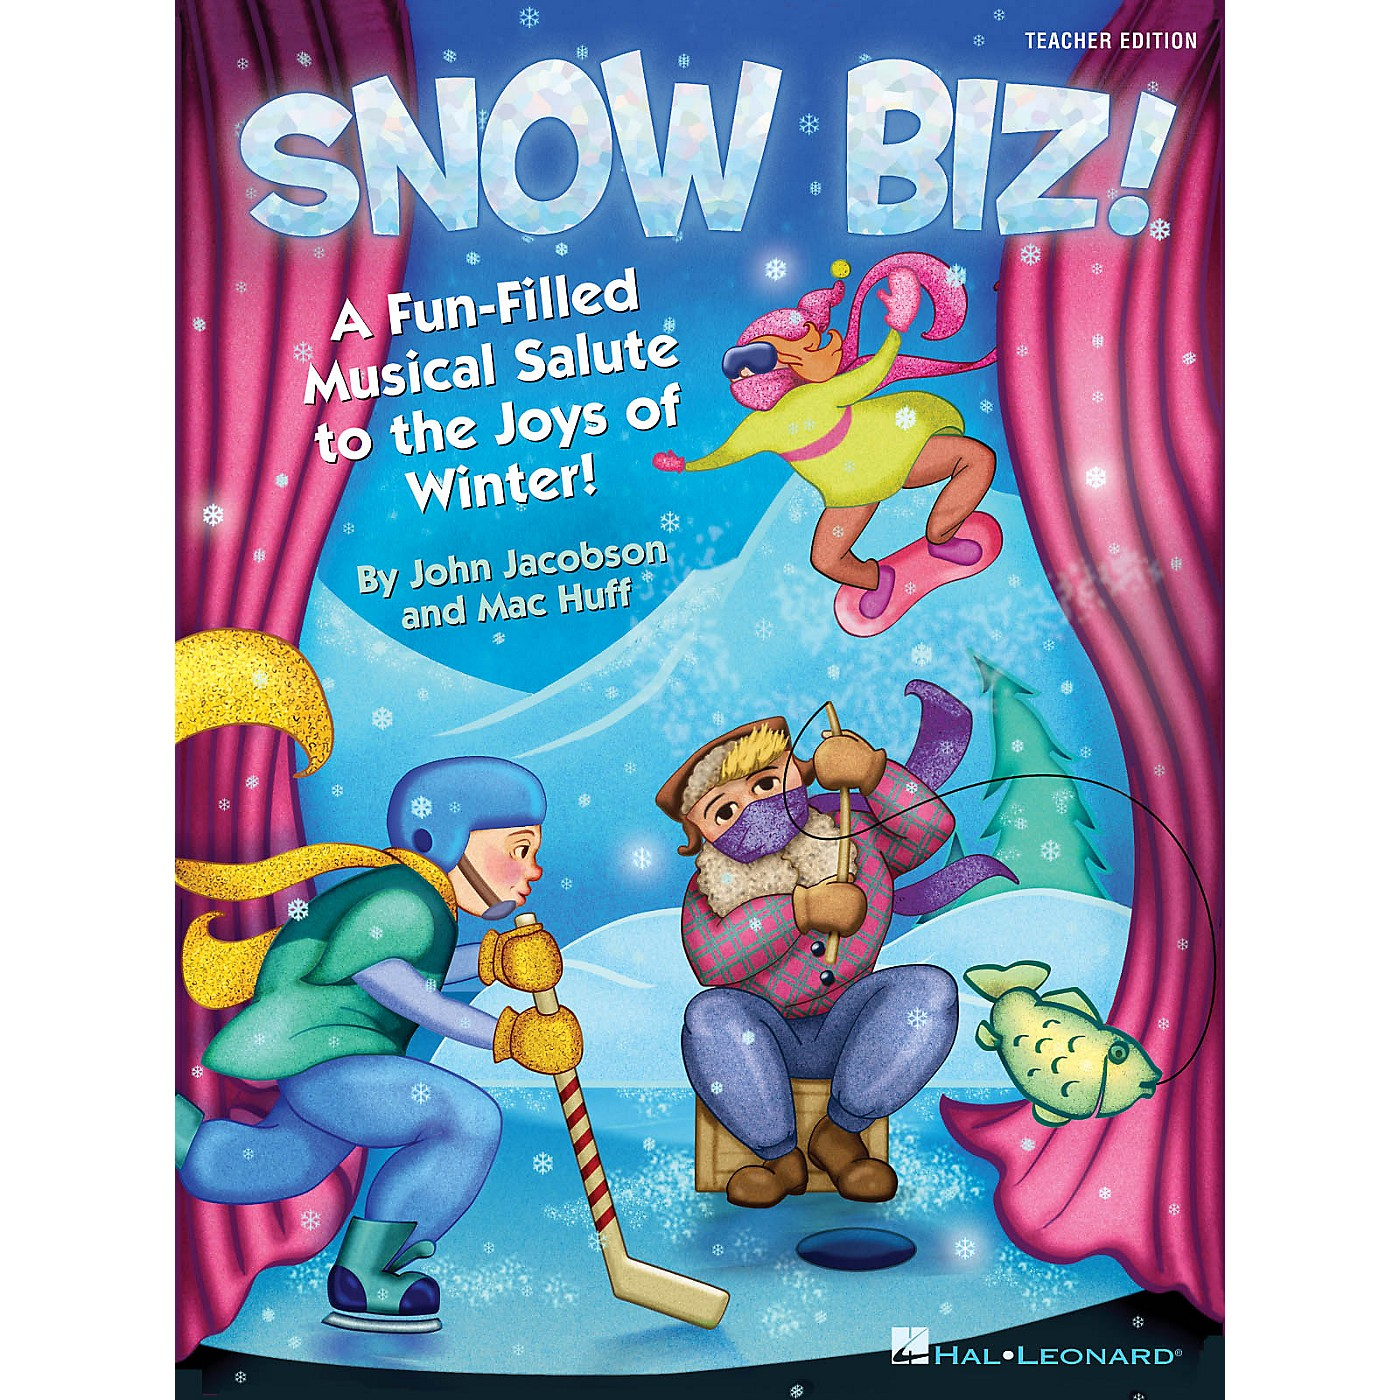What might be the significance of the whimsical creature in swimwear, and how does it align with the theme? The whimsical creature in swimwear adds a humorous and imaginative twist to the image, which can appeal strongly to a child's sense of fun and creativity. Its presence in a winter scene, despite wearing summer attire, brings a playful contrast that suggests a lighthearted and imaginative interpretation of winter. This element aligns with the theme by emphasizing that winter fun can be boundless and full of surprises, encouraging an imaginative and engaging approach to enjoying the season. It reinforces the idea that winter is not just about cold and snow but also about creativity and joy, which fits perfectly with the educational and entertaining goal of the material. 